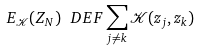<formula> <loc_0><loc_0><loc_500><loc_500>E _ { \mathcal { K } } ( Z _ { N } ) \ D E F \sum _ { j \neq k } \mathcal { K } ( z _ { j } , z _ { k } )</formula> 